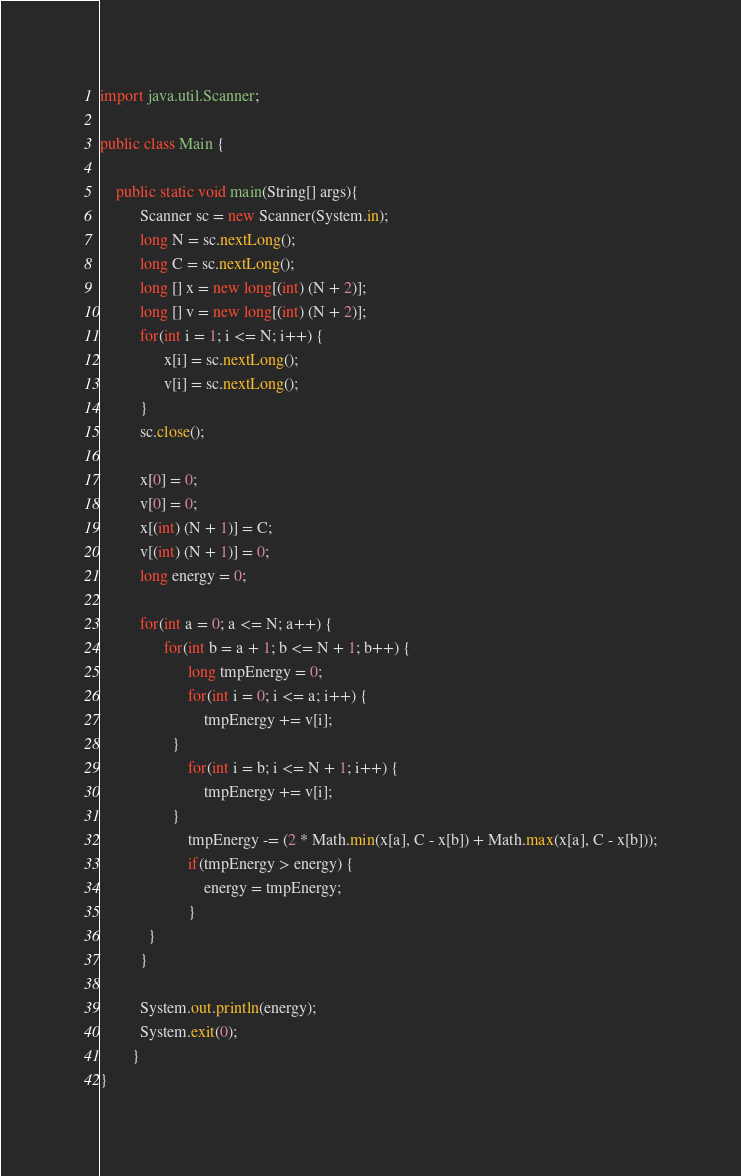Convert code to text. <code><loc_0><loc_0><loc_500><loc_500><_Java_>import java.util.Scanner;

public class Main {

	public static void main(String[] args){
	      Scanner sc = new Scanner(System.in);
	      long N = sc.nextLong();
	      long C = sc.nextLong();
	      long [] x = new long[(int) (N + 2)];
	      long [] v = new long[(int) (N + 2)];
	      for(int i = 1; i <= N; i++) {
	    	    x[i] = sc.nextLong();
	    	    v[i] = sc.nextLong();
		  }
	      sc.close();
	      
	      x[0] = 0;
	      v[0] = 0;
	      x[(int) (N + 1)] = C;
	      v[(int) (N + 1)] = 0;
	      long energy = 0;
	      
	      for(int a = 0; a <= N; a++) {
	    	    for(int b = a + 1; b <= N + 1; b++) {
	    	    	  long tmpEnergy = 0;
	    	    	  for(int i = 0; i <= a; i++) {
	    	    		  tmpEnergy += v[i];
	    		  }
	    	    	  for(int i = b; i <= N + 1; i++) {
	    	    		  tmpEnergy += v[i];
	    		  }
	    	    	  tmpEnergy -= (2 * Math.min(x[a], C - x[b]) + Math.max(x[a], C - x[b]));
	    	    	  if(tmpEnergy > energy) {
	    	    		  energy = tmpEnergy;
	    	    	  }
			}	
		  }
	      
	      System.out.println(energy);
	      System.exit(0);
	    }
}</code> 